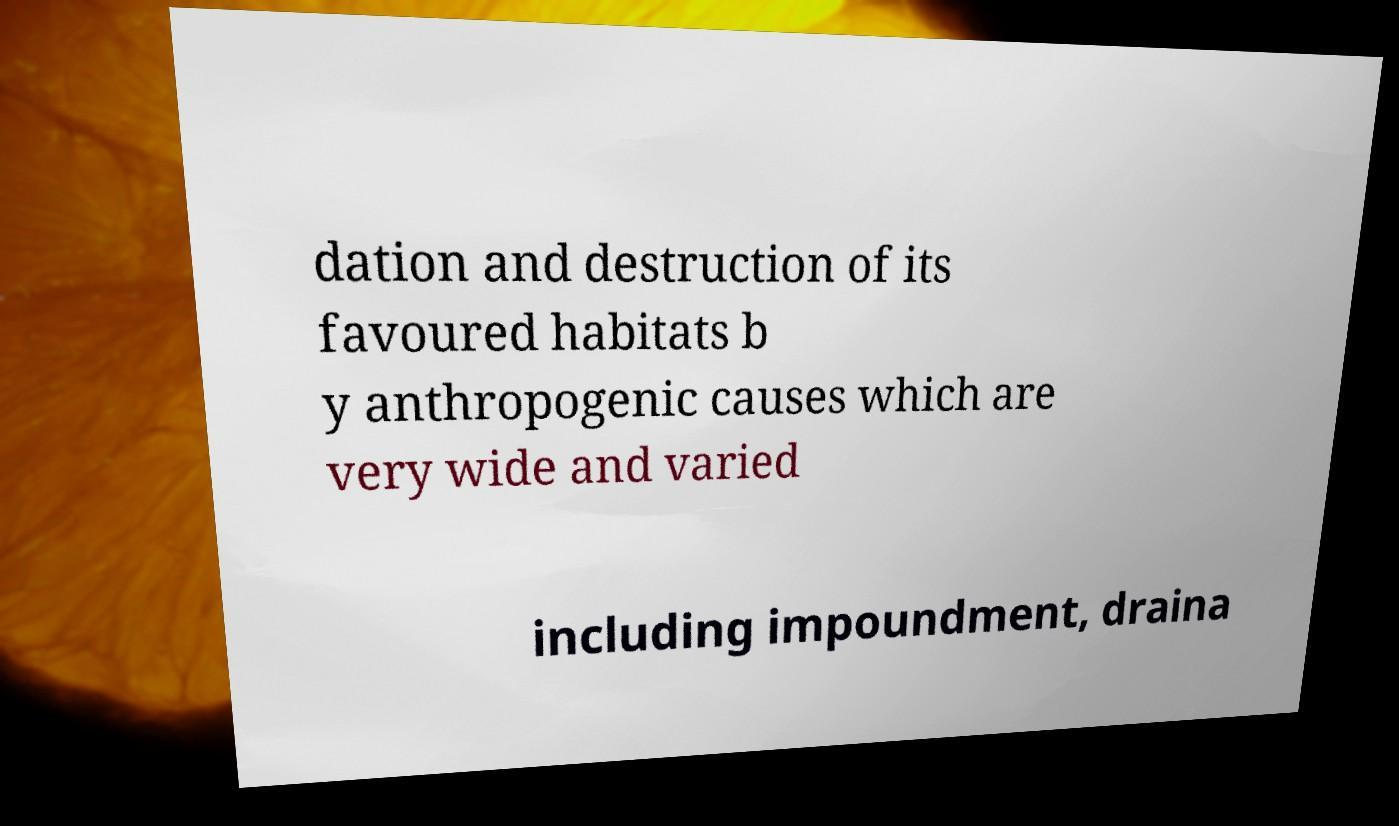Could you extract and type out the text from this image? dation and destruction of its favoured habitats b y anthropogenic causes which are very wide and varied including impoundment, draina 